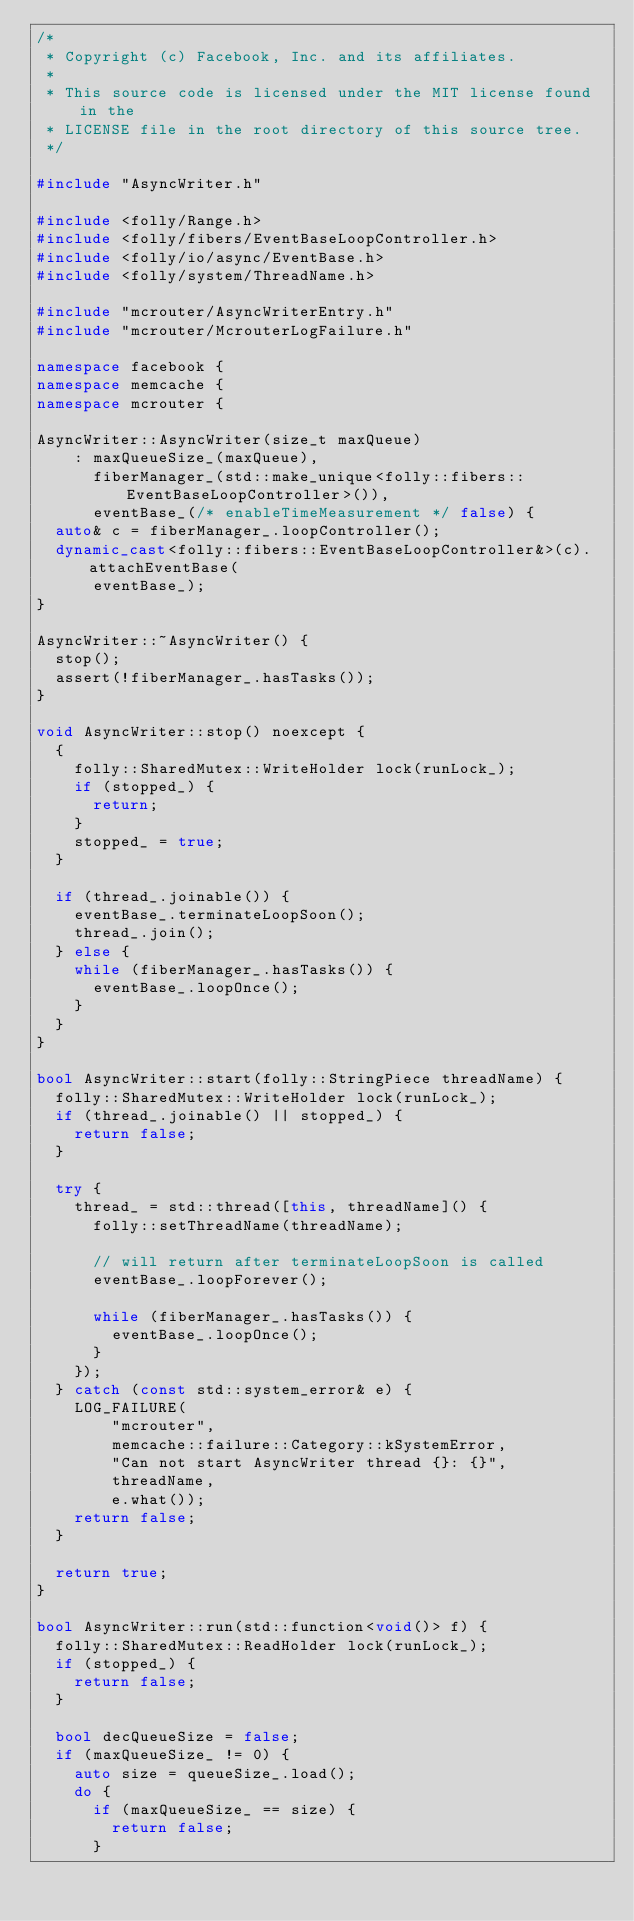Convert code to text. <code><loc_0><loc_0><loc_500><loc_500><_C++_>/*
 * Copyright (c) Facebook, Inc. and its affiliates.
 *
 * This source code is licensed under the MIT license found in the
 * LICENSE file in the root directory of this source tree.
 */

#include "AsyncWriter.h"

#include <folly/Range.h>
#include <folly/fibers/EventBaseLoopController.h>
#include <folly/io/async/EventBase.h>
#include <folly/system/ThreadName.h>

#include "mcrouter/AsyncWriterEntry.h"
#include "mcrouter/McrouterLogFailure.h"

namespace facebook {
namespace memcache {
namespace mcrouter {

AsyncWriter::AsyncWriter(size_t maxQueue)
    : maxQueueSize_(maxQueue),
      fiberManager_(std::make_unique<folly::fibers::EventBaseLoopController>()),
      eventBase_(/* enableTimeMeasurement */ false) {
  auto& c = fiberManager_.loopController();
  dynamic_cast<folly::fibers::EventBaseLoopController&>(c).attachEventBase(
      eventBase_);
}

AsyncWriter::~AsyncWriter() {
  stop();
  assert(!fiberManager_.hasTasks());
}

void AsyncWriter::stop() noexcept {
  {
    folly::SharedMutex::WriteHolder lock(runLock_);
    if (stopped_) {
      return;
    }
    stopped_ = true;
  }

  if (thread_.joinable()) {
    eventBase_.terminateLoopSoon();
    thread_.join();
  } else {
    while (fiberManager_.hasTasks()) {
      eventBase_.loopOnce();
    }
  }
}

bool AsyncWriter::start(folly::StringPiece threadName) {
  folly::SharedMutex::WriteHolder lock(runLock_);
  if (thread_.joinable() || stopped_) {
    return false;
  }

  try {
    thread_ = std::thread([this, threadName]() {
      folly::setThreadName(threadName);

      // will return after terminateLoopSoon is called
      eventBase_.loopForever();

      while (fiberManager_.hasTasks()) {
        eventBase_.loopOnce();
      }
    });
  } catch (const std::system_error& e) {
    LOG_FAILURE(
        "mcrouter",
        memcache::failure::Category::kSystemError,
        "Can not start AsyncWriter thread {}: {}",
        threadName,
        e.what());
    return false;
  }

  return true;
}

bool AsyncWriter::run(std::function<void()> f) {
  folly::SharedMutex::ReadHolder lock(runLock_);
  if (stopped_) {
    return false;
  }

  bool decQueueSize = false;
  if (maxQueueSize_ != 0) {
    auto size = queueSize_.load();
    do {
      if (maxQueueSize_ == size) {
        return false;
      }</code> 